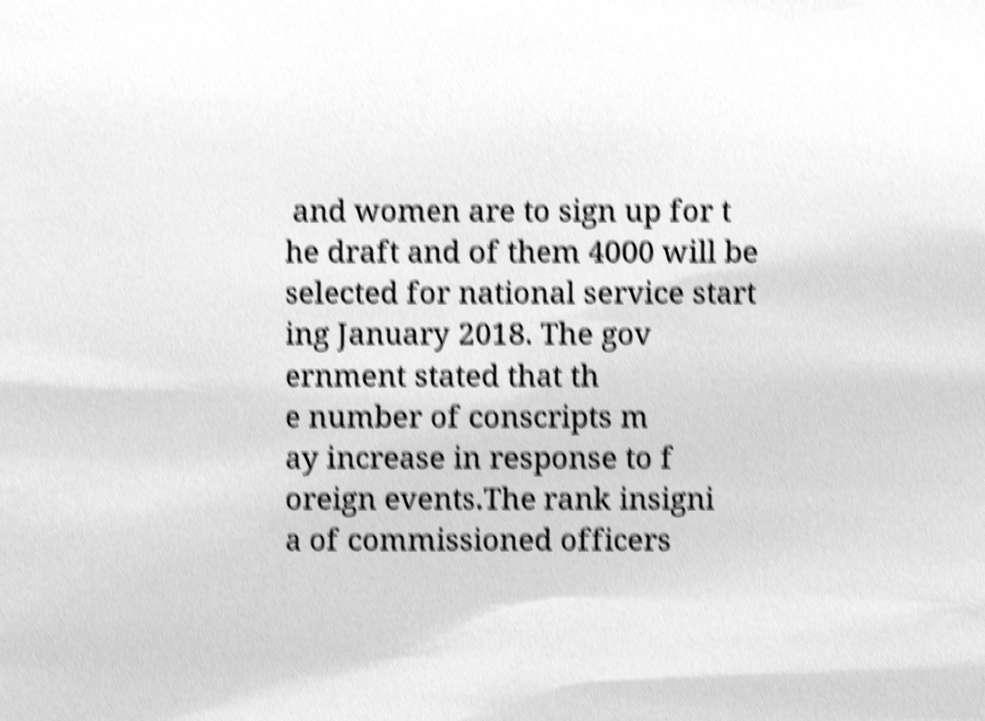Please read and relay the text visible in this image. What does it say? and women are to sign up for t he draft and of them 4000 will be selected for national service start ing January 2018. The gov ernment stated that th e number of conscripts m ay increase in response to f oreign events.The rank insigni a of commissioned officers 